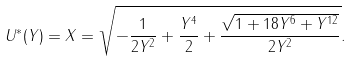Convert formula to latex. <formula><loc_0><loc_0><loc_500><loc_500>U ^ { * } ( Y ) = X = \sqrt { - \frac { 1 } { 2 Y ^ { 2 } } + \frac { Y ^ { 4 } } { 2 } + \frac { \sqrt { 1 + 1 8 Y ^ { 6 } + Y ^ { 1 2 } } } { 2 Y ^ { 2 } } } .</formula> 